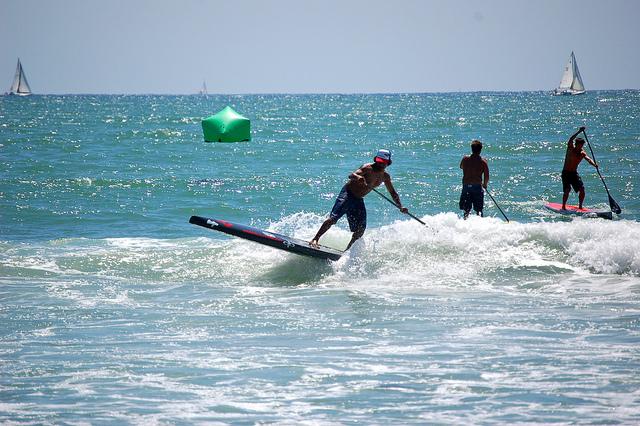How many sailboats are shown?
Answer briefly. 2. Is this a great wave for surfers?
Be succinct. No. Does the surfer on the left look like he will fall?
Answer briefly. Yes. What sport are the people engaged in?
Write a very short answer. Paddle boarding. 